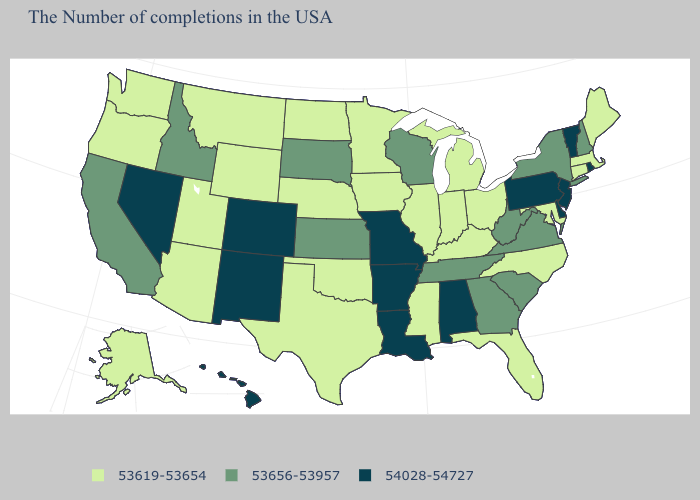Does Oklahoma have the lowest value in the USA?
Be succinct. Yes. Is the legend a continuous bar?
Short answer required. No. What is the highest value in the West ?
Write a very short answer. 54028-54727. What is the value of Colorado?
Give a very brief answer. 54028-54727. What is the value of Connecticut?
Answer briefly. 53619-53654. Name the states that have a value in the range 54028-54727?
Answer briefly. Rhode Island, Vermont, New Jersey, Delaware, Pennsylvania, Alabama, Louisiana, Missouri, Arkansas, Colorado, New Mexico, Nevada, Hawaii. Among the states that border Utah , which have the lowest value?
Answer briefly. Wyoming, Arizona. What is the value of Wisconsin?
Quick response, please. 53656-53957. What is the value of Virginia?
Short answer required. 53656-53957. Name the states that have a value in the range 53619-53654?
Quick response, please. Maine, Massachusetts, Connecticut, Maryland, North Carolina, Ohio, Florida, Michigan, Kentucky, Indiana, Illinois, Mississippi, Minnesota, Iowa, Nebraska, Oklahoma, Texas, North Dakota, Wyoming, Utah, Montana, Arizona, Washington, Oregon, Alaska. Is the legend a continuous bar?
Quick response, please. No. What is the value of Missouri?
Concise answer only. 54028-54727. What is the value of Tennessee?
Concise answer only. 53656-53957. Name the states that have a value in the range 54028-54727?
Concise answer only. Rhode Island, Vermont, New Jersey, Delaware, Pennsylvania, Alabama, Louisiana, Missouri, Arkansas, Colorado, New Mexico, Nevada, Hawaii. 